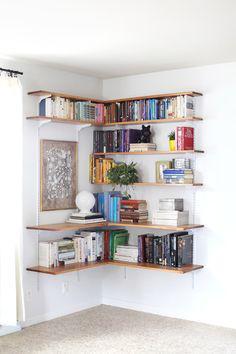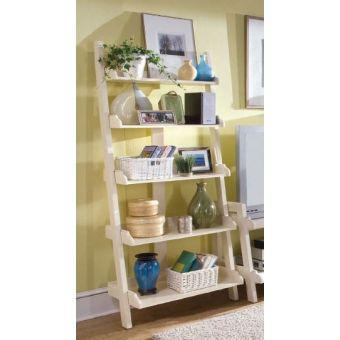The first image is the image on the left, the second image is the image on the right. Assess this claim about the two images: "One image shows a shelf unit with open back and sides that resembles a ladder leaning on a wall, and it is not positioned in a corner.". Correct or not? Answer yes or no. Yes. The first image is the image on the left, the second image is the image on the right. For the images shown, is this caption "In the image on the left, the shelves are placed in a corner." true? Answer yes or no. Yes. 